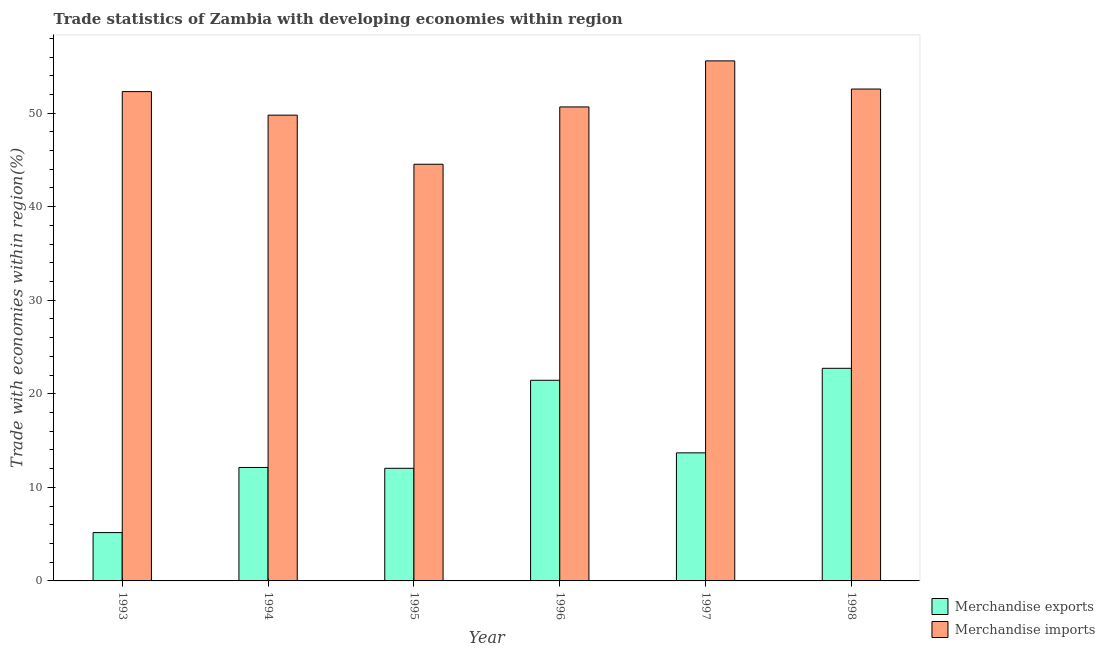Are the number of bars per tick equal to the number of legend labels?
Ensure brevity in your answer.  Yes. Are the number of bars on each tick of the X-axis equal?
Your answer should be compact. Yes. How many bars are there on the 3rd tick from the left?
Your answer should be compact. 2. How many bars are there on the 5th tick from the right?
Provide a short and direct response. 2. What is the label of the 3rd group of bars from the left?
Your answer should be very brief. 1995. What is the merchandise exports in 1996?
Offer a terse response. 21.45. Across all years, what is the maximum merchandise imports?
Ensure brevity in your answer.  55.59. Across all years, what is the minimum merchandise exports?
Give a very brief answer. 5.17. In which year was the merchandise exports maximum?
Provide a short and direct response. 1998. In which year was the merchandise imports minimum?
Offer a very short reply. 1995. What is the total merchandise imports in the graph?
Provide a succinct answer. 305.46. What is the difference between the merchandise imports in 1994 and that in 1997?
Your response must be concise. -5.8. What is the difference between the merchandise exports in 1994 and the merchandise imports in 1995?
Make the answer very short. 0.09. What is the average merchandise imports per year?
Offer a very short reply. 50.91. In how many years, is the merchandise imports greater than 46 %?
Keep it short and to the point. 5. What is the ratio of the merchandise exports in 1997 to that in 1998?
Your answer should be very brief. 0.6. Is the difference between the merchandise exports in 1993 and 1998 greater than the difference between the merchandise imports in 1993 and 1998?
Provide a short and direct response. No. What is the difference between the highest and the second highest merchandise imports?
Your answer should be very brief. 3.01. What is the difference between the highest and the lowest merchandise imports?
Give a very brief answer. 11.05. Is the sum of the merchandise imports in 1994 and 1995 greater than the maximum merchandise exports across all years?
Offer a very short reply. Yes. How many bars are there?
Ensure brevity in your answer.  12. Are all the bars in the graph horizontal?
Give a very brief answer. No. How many years are there in the graph?
Your answer should be compact. 6. What is the difference between two consecutive major ticks on the Y-axis?
Your answer should be very brief. 10. Does the graph contain any zero values?
Your answer should be compact. No. Does the graph contain grids?
Provide a succinct answer. No. Where does the legend appear in the graph?
Ensure brevity in your answer.  Bottom right. How many legend labels are there?
Offer a very short reply. 2. How are the legend labels stacked?
Your response must be concise. Vertical. What is the title of the graph?
Offer a terse response. Trade statistics of Zambia with developing economies within region. Does "Female labourers" appear as one of the legend labels in the graph?
Offer a very short reply. No. What is the label or title of the Y-axis?
Give a very brief answer. Trade with economies within region(%). What is the Trade with economies within region(%) in Merchandise exports in 1993?
Keep it short and to the point. 5.17. What is the Trade with economies within region(%) of Merchandise imports in 1993?
Provide a succinct answer. 52.3. What is the Trade with economies within region(%) in Merchandise exports in 1994?
Your response must be concise. 12.13. What is the Trade with economies within region(%) of Merchandise imports in 1994?
Provide a short and direct response. 49.79. What is the Trade with economies within region(%) in Merchandise exports in 1995?
Ensure brevity in your answer.  12.04. What is the Trade with economies within region(%) of Merchandise imports in 1995?
Give a very brief answer. 44.54. What is the Trade with economies within region(%) of Merchandise exports in 1996?
Ensure brevity in your answer.  21.45. What is the Trade with economies within region(%) of Merchandise imports in 1996?
Make the answer very short. 50.67. What is the Trade with economies within region(%) in Merchandise exports in 1997?
Give a very brief answer. 13.69. What is the Trade with economies within region(%) in Merchandise imports in 1997?
Your answer should be compact. 55.59. What is the Trade with economies within region(%) of Merchandise exports in 1998?
Offer a very short reply. 22.73. What is the Trade with economies within region(%) in Merchandise imports in 1998?
Your answer should be very brief. 52.58. Across all years, what is the maximum Trade with economies within region(%) of Merchandise exports?
Keep it short and to the point. 22.73. Across all years, what is the maximum Trade with economies within region(%) of Merchandise imports?
Your response must be concise. 55.59. Across all years, what is the minimum Trade with economies within region(%) of Merchandise exports?
Keep it short and to the point. 5.17. Across all years, what is the minimum Trade with economies within region(%) in Merchandise imports?
Your answer should be compact. 44.54. What is the total Trade with economies within region(%) in Merchandise exports in the graph?
Offer a terse response. 87.19. What is the total Trade with economies within region(%) in Merchandise imports in the graph?
Offer a very short reply. 305.46. What is the difference between the Trade with economies within region(%) of Merchandise exports in 1993 and that in 1994?
Your response must be concise. -6.96. What is the difference between the Trade with economies within region(%) in Merchandise imports in 1993 and that in 1994?
Keep it short and to the point. 2.52. What is the difference between the Trade with economies within region(%) in Merchandise exports in 1993 and that in 1995?
Offer a very short reply. -6.87. What is the difference between the Trade with economies within region(%) in Merchandise imports in 1993 and that in 1995?
Offer a terse response. 7.77. What is the difference between the Trade with economies within region(%) of Merchandise exports in 1993 and that in 1996?
Your answer should be compact. -16.28. What is the difference between the Trade with economies within region(%) in Merchandise imports in 1993 and that in 1996?
Provide a succinct answer. 1.64. What is the difference between the Trade with economies within region(%) in Merchandise exports in 1993 and that in 1997?
Provide a succinct answer. -8.52. What is the difference between the Trade with economies within region(%) in Merchandise imports in 1993 and that in 1997?
Your answer should be compact. -3.28. What is the difference between the Trade with economies within region(%) of Merchandise exports in 1993 and that in 1998?
Your answer should be very brief. -17.56. What is the difference between the Trade with economies within region(%) of Merchandise imports in 1993 and that in 1998?
Make the answer very short. -0.27. What is the difference between the Trade with economies within region(%) in Merchandise exports in 1994 and that in 1995?
Your response must be concise. 0.09. What is the difference between the Trade with economies within region(%) in Merchandise imports in 1994 and that in 1995?
Your answer should be very brief. 5.25. What is the difference between the Trade with economies within region(%) of Merchandise exports in 1994 and that in 1996?
Your answer should be compact. -9.32. What is the difference between the Trade with economies within region(%) in Merchandise imports in 1994 and that in 1996?
Give a very brief answer. -0.88. What is the difference between the Trade with economies within region(%) in Merchandise exports in 1994 and that in 1997?
Your answer should be compact. -1.56. What is the difference between the Trade with economies within region(%) of Merchandise imports in 1994 and that in 1997?
Give a very brief answer. -5.8. What is the difference between the Trade with economies within region(%) in Merchandise exports in 1994 and that in 1998?
Offer a very short reply. -10.6. What is the difference between the Trade with economies within region(%) of Merchandise imports in 1994 and that in 1998?
Your answer should be very brief. -2.79. What is the difference between the Trade with economies within region(%) in Merchandise exports in 1995 and that in 1996?
Ensure brevity in your answer.  -9.41. What is the difference between the Trade with economies within region(%) in Merchandise imports in 1995 and that in 1996?
Your answer should be compact. -6.13. What is the difference between the Trade with economies within region(%) of Merchandise exports in 1995 and that in 1997?
Provide a succinct answer. -1.65. What is the difference between the Trade with economies within region(%) in Merchandise imports in 1995 and that in 1997?
Keep it short and to the point. -11.05. What is the difference between the Trade with economies within region(%) of Merchandise exports in 1995 and that in 1998?
Make the answer very short. -10.69. What is the difference between the Trade with economies within region(%) of Merchandise imports in 1995 and that in 1998?
Provide a succinct answer. -8.04. What is the difference between the Trade with economies within region(%) of Merchandise exports in 1996 and that in 1997?
Keep it short and to the point. 7.76. What is the difference between the Trade with economies within region(%) of Merchandise imports in 1996 and that in 1997?
Give a very brief answer. -4.92. What is the difference between the Trade with economies within region(%) of Merchandise exports in 1996 and that in 1998?
Offer a very short reply. -1.28. What is the difference between the Trade with economies within region(%) of Merchandise imports in 1996 and that in 1998?
Your response must be concise. -1.91. What is the difference between the Trade with economies within region(%) of Merchandise exports in 1997 and that in 1998?
Your answer should be very brief. -9.04. What is the difference between the Trade with economies within region(%) in Merchandise imports in 1997 and that in 1998?
Offer a terse response. 3.01. What is the difference between the Trade with economies within region(%) in Merchandise exports in 1993 and the Trade with economies within region(%) in Merchandise imports in 1994?
Give a very brief answer. -44.62. What is the difference between the Trade with economies within region(%) in Merchandise exports in 1993 and the Trade with economies within region(%) in Merchandise imports in 1995?
Offer a very short reply. -39.37. What is the difference between the Trade with economies within region(%) in Merchandise exports in 1993 and the Trade with economies within region(%) in Merchandise imports in 1996?
Make the answer very short. -45.5. What is the difference between the Trade with economies within region(%) of Merchandise exports in 1993 and the Trade with economies within region(%) of Merchandise imports in 1997?
Give a very brief answer. -50.42. What is the difference between the Trade with economies within region(%) in Merchandise exports in 1993 and the Trade with economies within region(%) in Merchandise imports in 1998?
Ensure brevity in your answer.  -47.41. What is the difference between the Trade with economies within region(%) in Merchandise exports in 1994 and the Trade with economies within region(%) in Merchandise imports in 1995?
Give a very brief answer. -32.41. What is the difference between the Trade with economies within region(%) in Merchandise exports in 1994 and the Trade with economies within region(%) in Merchandise imports in 1996?
Make the answer very short. -38.54. What is the difference between the Trade with economies within region(%) in Merchandise exports in 1994 and the Trade with economies within region(%) in Merchandise imports in 1997?
Provide a succinct answer. -43.46. What is the difference between the Trade with economies within region(%) in Merchandise exports in 1994 and the Trade with economies within region(%) in Merchandise imports in 1998?
Your response must be concise. -40.45. What is the difference between the Trade with economies within region(%) of Merchandise exports in 1995 and the Trade with economies within region(%) of Merchandise imports in 1996?
Keep it short and to the point. -38.63. What is the difference between the Trade with economies within region(%) of Merchandise exports in 1995 and the Trade with economies within region(%) of Merchandise imports in 1997?
Provide a short and direct response. -43.55. What is the difference between the Trade with economies within region(%) in Merchandise exports in 1995 and the Trade with economies within region(%) in Merchandise imports in 1998?
Your response must be concise. -40.54. What is the difference between the Trade with economies within region(%) of Merchandise exports in 1996 and the Trade with economies within region(%) of Merchandise imports in 1997?
Make the answer very short. -34.14. What is the difference between the Trade with economies within region(%) in Merchandise exports in 1996 and the Trade with economies within region(%) in Merchandise imports in 1998?
Offer a very short reply. -31.13. What is the difference between the Trade with economies within region(%) of Merchandise exports in 1997 and the Trade with economies within region(%) of Merchandise imports in 1998?
Give a very brief answer. -38.89. What is the average Trade with economies within region(%) in Merchandise exports per year?
Provide a short and direct response. 14.53. What is the average Trade with economies within region(%) of Merchandise imports per year?
Give a very brief answer. 50.91. In the year 1993, what is the difference between the Trade with economies within region(%) of Merchandise exports and Trade with economies within region(%) of Merchandise imports?
Offer a very short reply. -47.14. In the year 1994, what is the difference between the Trade with economies within region(%) in Merchandise exports and Trade with economies within region(%) in Merchandise imports?
Your response must be concise. -37.66. In the year 1995, what is the difference between the Trade with economies within region(%) in Merchandise exports and Trade with economies within region(%) in Merchandise imports?
Provide a succinct answer. -32.5. In the year 1996, what is the difference between the Trade with economies within region(%) of Merchandise exports and Trade with economies within region(%) of Merchandise imports?
Give a very brief answer. -29.22. In the year 1997, what is the difference between the Trade with economies within region(%) of Merchandise exports and Trade with economies within region(%) of Merchandise imports?
Ensure brevity in your answer.  -41.9. In the year 1998, what is the difference between the Trade with economies within region(%) in Merchandise exports and Trade with economies within region(%) in Merchandise imports?
Make the answer very short. -29.85. What is the ratio of the Trade with economies within region(%) of Merchandise exports in 1993 to that in 1994?
Provide a short and direct response. 0.43. What is the ratio of the Trade with economies within region(%) of Merchandise imports in 1993 to that in 1994?
Keep it short and to the point. 1.05. What is the ratio of the Trade with economies within region(%) of Merchandise exports in 1993 to that in 1995?
Keep it short and to the point. 0.43. What is the ratio of the Trade with economies within region(%) in Merchandise imports in 1993 to that in 1995?
Keep it short and to the point. 1.17. What is the ratio of the Trade with economies within region(%) of Merchandise exports in 1993 to that in 1996?
Keep it short and to the point. 0.24. What is the ratio of the Trade with economies within region(%) of Merchandise imports in 1993 to that in 1996?
Make the answer very short. 1.03. What is the ratio of the Trade with economies within region(%) in Merchandise exports in 1993 to that in 1997?
Provide a succinct answer. 0.38. What is the ratio of the Trade with economies within region(%) in Merchandise imports in 1993 to that in 1997?
Give a very brief answer. 0.94. What is the ratio of the Trade with economies within region(%) in Merchandise exports in 1993 to that in 1998?
Your response must be concise. 0.23. What is the ratio of the Trade with economies within region(%) in Merchandise exports in 1994 to that in 1995?
Give a very brief answer. 1.01. What is the ratio of the Trade with economies within region(%) of Merchandise imports in 1994 to that in 1995?
Your answer should be compact. 1.12. What is the ratio of the Trade with economies within region(%) in Merchandise exports in 1994 to that in 1996?
Offer a terse response. 0.57. What is the ratio of the Trade with economies within region(%) in Merchandise imports in 1994 to that in 1996?
Give a very brief answer. 0.98. What is the ratio of the Trade with economies within region(%) of Merchandise exports in 1994 to that in 1997?
Give a very brief answer. 0.89. What is the ratio of the Trade with economies within region(%) in Merchandise imports in 1994 to that in 1997?
Your answer should be very brief. 0.9. What is the ratio of the Trade with economies within region(%) of Merchandise exports in 1994 to that in 1998?
Ensure brevity in your answer.  0.53. What is the ratio of the Trade with economies within region(%) of Merchandise imports in 1994 to that in 1998?
Make the answer very short. 0.95. What is the ratio of the Trade with economies within region(%) of Merchandise exports in 1995 to that in 1996?
Give a very brief answer. 0.56. What is the ratio of the Trade with economies within region(%) in Merchandise imports in 1995 to that in 1996?
Ensure brevity in your answer.  0.88. What is the ratio of the Trade with economies within region(%) of Merchandise exports in 1995 to that in 1997?
Give a very brief answer. 0.88. What is the ratio of the Trade with economies within region(%) in Merchandise imports in 1995 to that in 1997?
Your answer should be compact. 0.8. What is the ratio of the Trade with economies within region(%) of Merchandise exports in 1995 to that in 1998?
Offer a terse response. 0.53. What is the ratio of the Trade with economies within region(%) in Merchandise imports in 1995 to that in 1998?
Provide a succinct answer. 0.85. What is the ratio of the Trade with economies within region(%) in Merchandise exports in 1996 to that in 1997?
Your answer should be compact. 1.57. What is the ratio of the Trade with economies within region(%) of Merchandise imports in 1996 to that in 1997?
Provide a succinct answer. 0.91. What is the ratio of the Trade with economies within region(%) in Merchandise exports in 1996 to that in 1998?
Provide a short and direct response. 0.94. What is the ratio of the Trade with economies within region(%) of Merchandise imports in 1996 to that in 1998?
Keep it short and to the point. 0.96. What is the ratio of the Trade with economies within region(%) of Merchandise exports in 1997 to that in 1998?
Ensure brevity in your answer.  0.6. What is the ratio of the Trade with economies within region(%) of Merchandise imports in 1997 to that in 1998?
Your answer should be very brief. 1.06. What is the difference between the highest and the second highest Trade with economies within region(%) in Merchandise exports?
Your response must be concise. 1.28. What is the difference between the highest and the second highest Trade with economies within region(%) of Merchandise imports?
Provide a short and direct response. 3.01. What is the difference between the highest and the lowest Trade with economies within region(%) of Merchandise exports?
Make the answer very short. 17.56. What is the difference between the highest and the lowest Trade with economies within region(%) of Merchandise imports?
Provide a succinct answer. 11.05. 